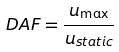Convert formula to latex. <formula><loc_0><loc_0><loc_500><loc_500>D A F = \frac { u _ { \max } } { u _ { s t a t i c } }</formula> 